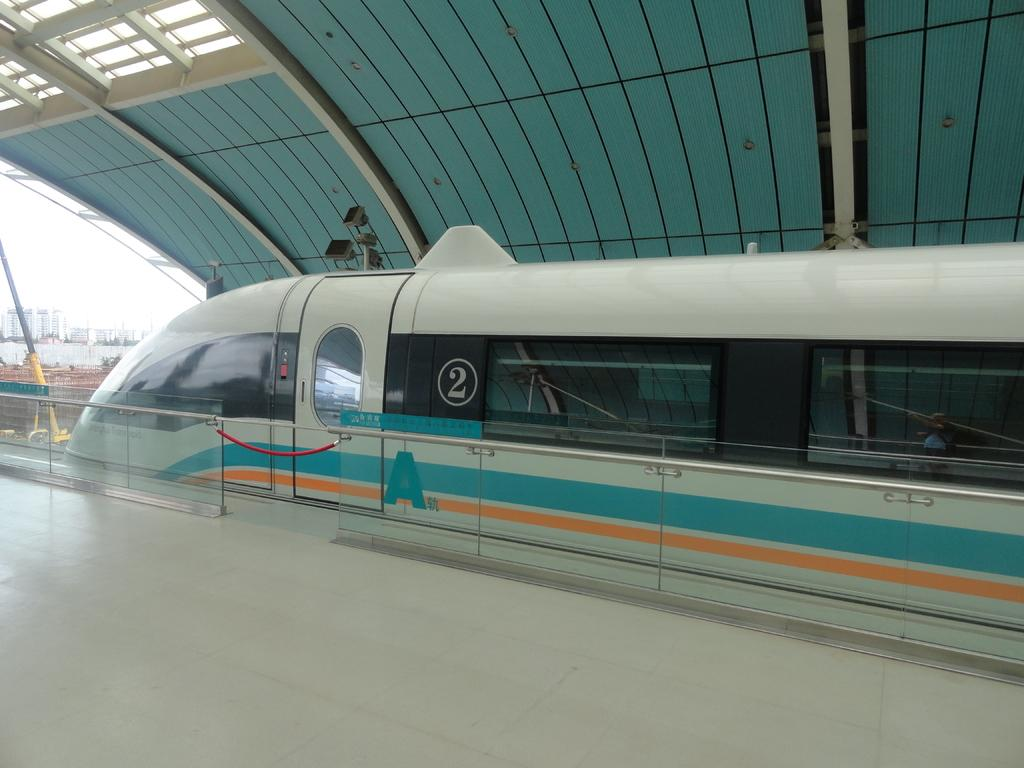What is the main subject of the image? The main subject of the image is a train on the track. What can be seen in the background of the image? There is a fence, the floor, lights, a roof, a pole, and buildings visible on the left side of the image. What part of the natural environment is visible in the image? The sky is visible in the image. What type of activity is the cup participating in on the page? There is no cup or page present in the image, so this question cannot be answered. 